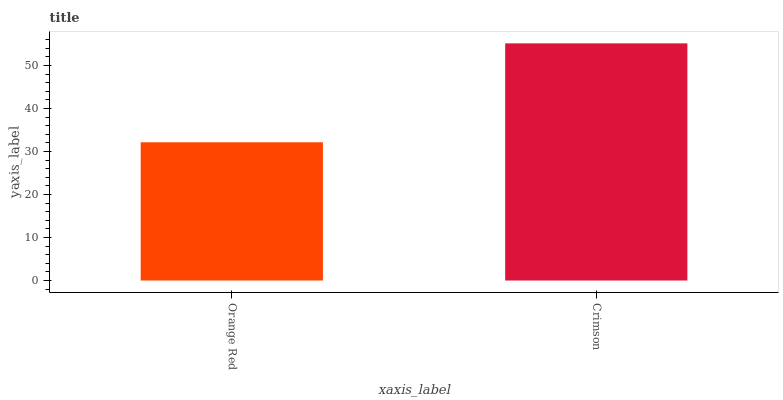Is Orange Red the minimum?
Answer yes or no. Yes. Is Crimson the maximum?
Answer yes or no. Yes. Is Crimson the minimum?
Answer yes or no. No. Is Crimson greater than Orange Red?
Answer yes or no. Yes. Is Orange Red less than Crimson?
Answer yes or no. Yes. Is Orange Red greater than Crimson?
Answer yes or no. No. Is Crimson less than Orange Red?
Answer yes or no. No. Is Crimson the high median?
Answer yes or no. Yes. Is Orange Red the low median?
Answer yes or no. Yes. Is Orange Red the high median?
Answer yes or no. No. Is Crimson the low median?
Answer yes or no. No. 